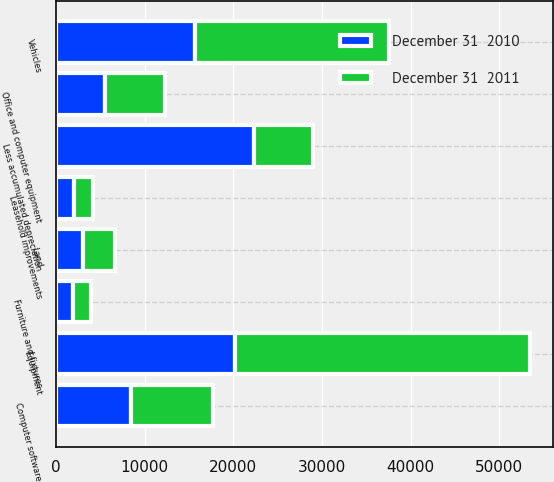Convert chart. <chart><loc_0><loc_0><loc_500><loc_500><stacked_bar_chart><ecel><fcel>Land<fcel>Leasehold improvements<fcel>Furniture and fixtures<fcel>Office and computer equipment<fcel>Computer software<fcel>Equipment<fcel>Vehicles<fcel>Less accumulated depreciation<nl><fcel>December 31  2011<fcel>3626<fcel>2132<fcel>2000<fcel>6727<fcel>9303<fcel>33286<fcel>21827<fcel>6727<nl><fcel>December 31  2010<fcel>3076<fcel>1998<fcel>1959<fcel>5541<fcel>8428<fcel>20150<fcel>15696<fcel>22297<nl></chart> 